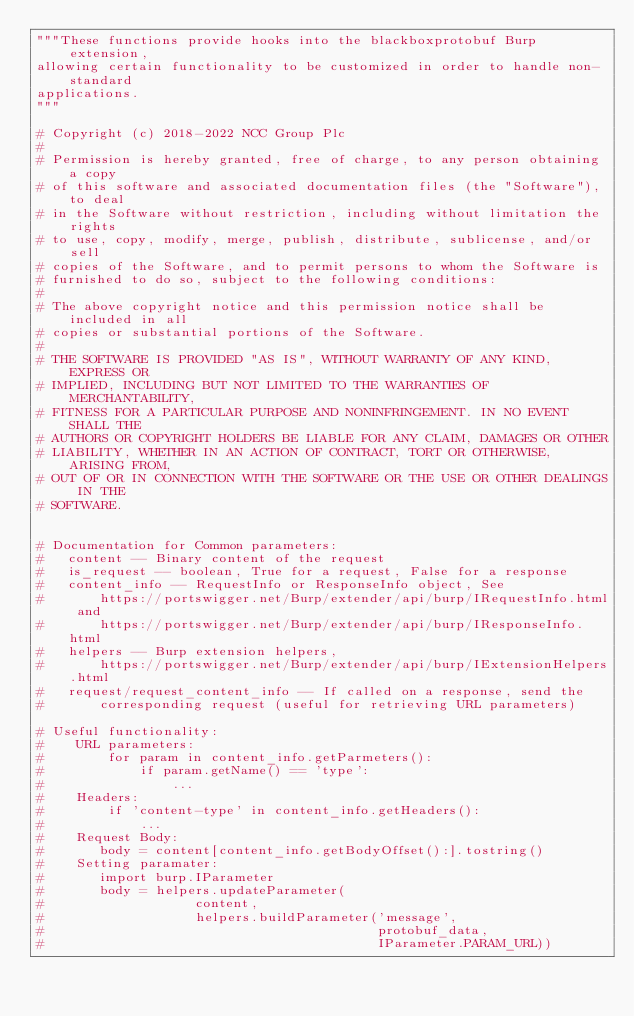<code> <loc_0><loc_0><loc_500><loc_500><_Python_>"""These functions provide hooks into the blackboxprotobuf Burp extension,
allowing certain functionality to be customized in order to handle non-standard
applications.
"""

# Copyright (c) 2018-2022 NCC Group Plc
#
# Permission is hereby granted, free of charge, to any person obtaining a copy
# of this software and associated documentation files (the "Software"), to deal
# in the Software without restriction, including without limitation the rights
# to use, copy, modify, merge, publish, distribute, sublicense, and/or sell
# copies of the Software, and to permit persons to whom the Software is
# furnished to do so, subject to the following conditions:
#
# The above copyright notice and this permission notice shall be included in all
# copies or substantial portions of the Software.
#
# THE SOFTWARE IS PROVIDED "AS IS", WITHOUT WARRANTY OF ANY KIND, EXPRESS OR
# IMPLIED, INCLUDING BUT NOT LIMITED TO THE WARRANTIES OF MERCHANTABILITY,
# FITNESS FOR A PARTICULAR PURPOSE AND NONINFRINGEMENT. IN NO EVENT SHALL THE
# AUTHORS OR COPYRIGHT HOLDERS BE LIABLE FOR ANY CLAIM, DAMAGES OR OTHER
# LIABILITY, WHETHER IN AN ACTION OF CONTRACT, TORT OR OTHERWISE, ARISING FROM,
# OUT OF OR IN CONNECTION WITH THE SOFTWARE OR THE USE OR OTHER DEALINGS IN THE
# SOFTWARE.


# Documentation for Common parameters:
#   content -- Binary content of the request
#   is_request -- boolean, True for a request, False for a response
#   content_info -- RequestInfo or ResponseInfo object, See
#       https://portswigger.net/Burp/extender/api/burp/IRequestInfo.html and
#       https://portswigger.net/Burp/extender/api/burp/IResponseInfo.html
#   helpers -- Burp extension helpers,
#       https://portswigger.net/Burp/extender/api/burp/IExtensionHelpers.html
#   request/request_content_info -- If called on a response, send the
#       corresponding request (useful for retrieving URL parameters)

# Useful functionality:
#    URL parameters:
#        for param in content_info.getParmeters():
#            if param.getName() == 'type':
#                ...
#    Headers:
#        if 'content-type' in content_info.getHeaders():
#            ...
#    Request Body:
#       body = content[content_info.getBodyOffset():].tostring()
#    Setting paramater:
#       import burp.IParameter
#       body = helpers.updateParameter(
#                   content,
#                   helpers.buildParameter('message',
#                                          protobuf_data,
#                                          IParameter.PARAM_URL))

</code> 